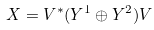<formula> <loc_0><loc_0><loc_500><loc_500>X = V ^ { * } ( Y ^ { 1 } \oplus Y ^ { 2 } ) V</formula> 